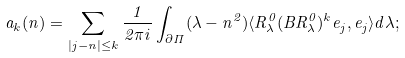Convert formula to latex. <formula><loc_0><loc_0><loc_500><loc_500>a _ { k } ( n ) = \sum _ { | j - n | \leq k } \frac { 1 } { 2 \pi i } \int _ { \partial \Pi } ( \lambda - n ^ { 2 } ) \langle R ^ { 0 } _ { \lambda } ( B R ^ { 0 } _ { \lambda } ) ^ { k } e _ { j } , e _ { j } \rangle d \lambda ;</formula> 